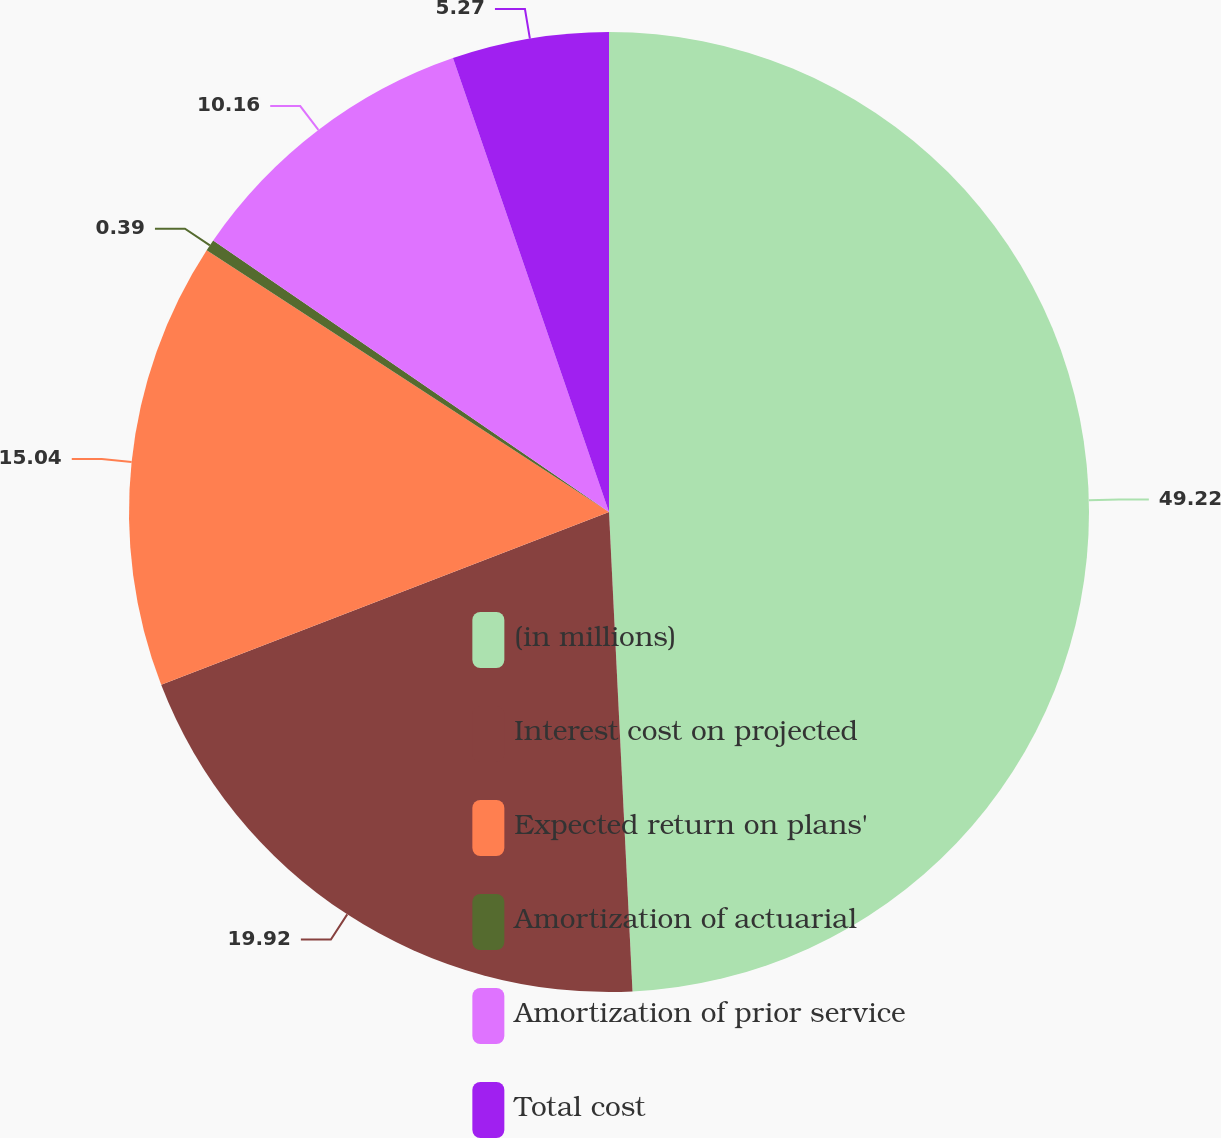Convert chart to OTSL. <chart><loc_0><loc_0><loc_500><loc_500><pie_chart><fcel>(in millions)<fcel>Interest cost on projected<fcel>Expected return on plans'<fcel>Amortization of actuarial<fcel>Amortization of prior service<fcel>Total cost<nl><fcel>49.22%<fcel>19.92%<fcel>15.04%<fcel>0.39%<fcel>10.16%<fcel>5.27%<nl></chart> 